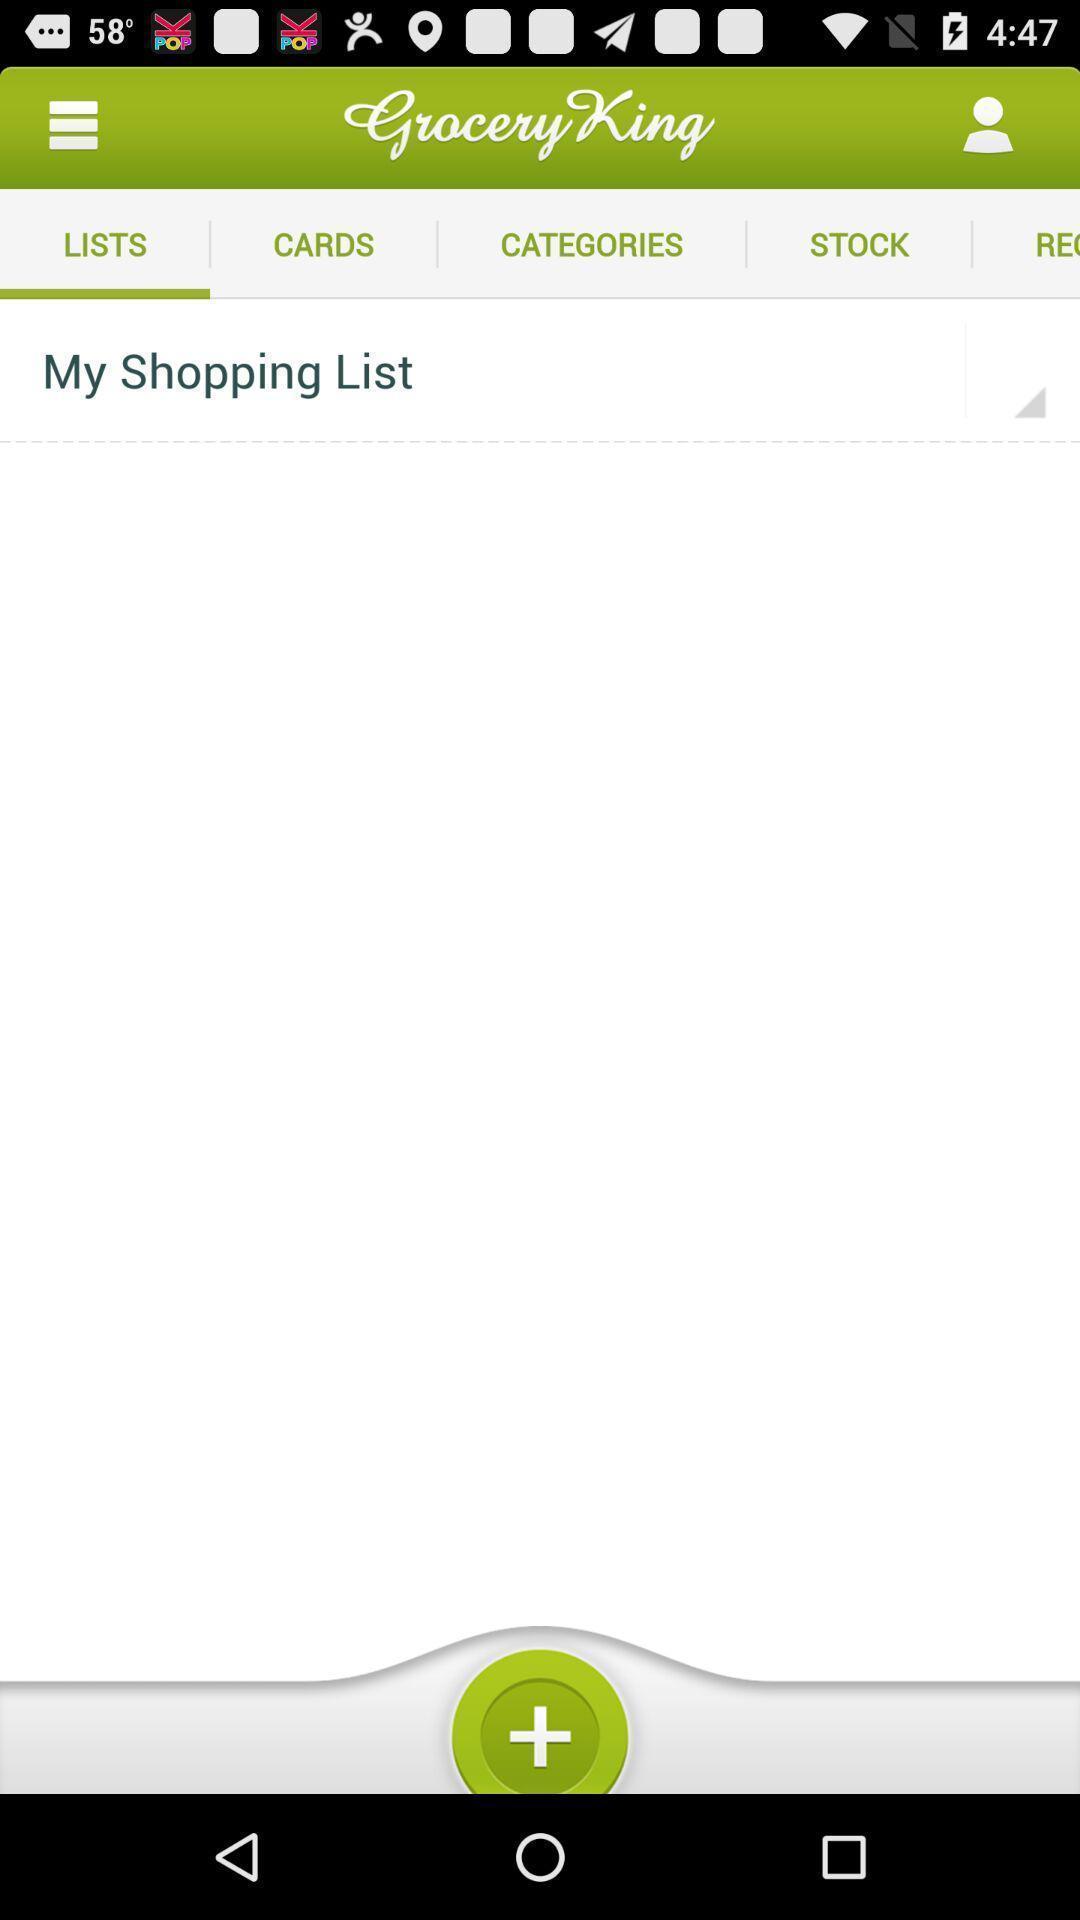Describe the content in this image. Shopping list page of a shopping app. 